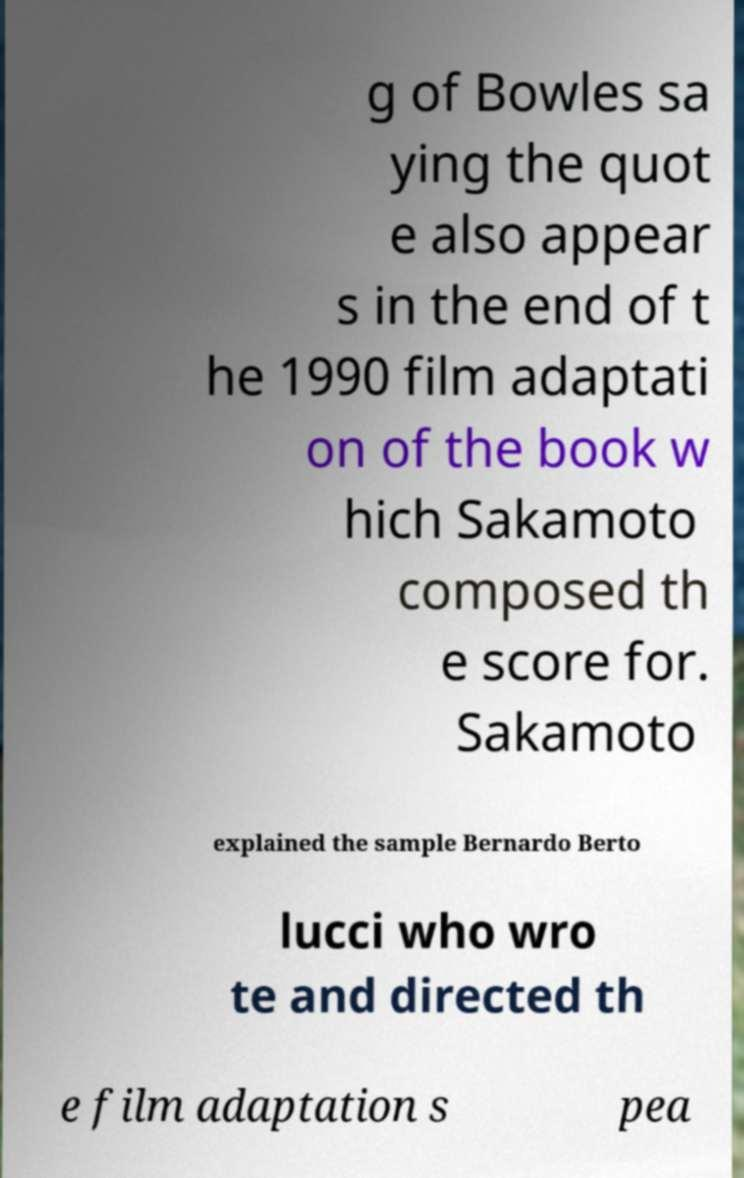I need the written content from this picture converted into text. Can you do that? g of Bowles sa ying the quot e also appear s in the end of t he 1990 film adaptati on of the book w hich Sakamoto composed th e score for. Sakamoto explained the sample Bernardo Berto lucci who wro te and directed th e film adaptation s pea 